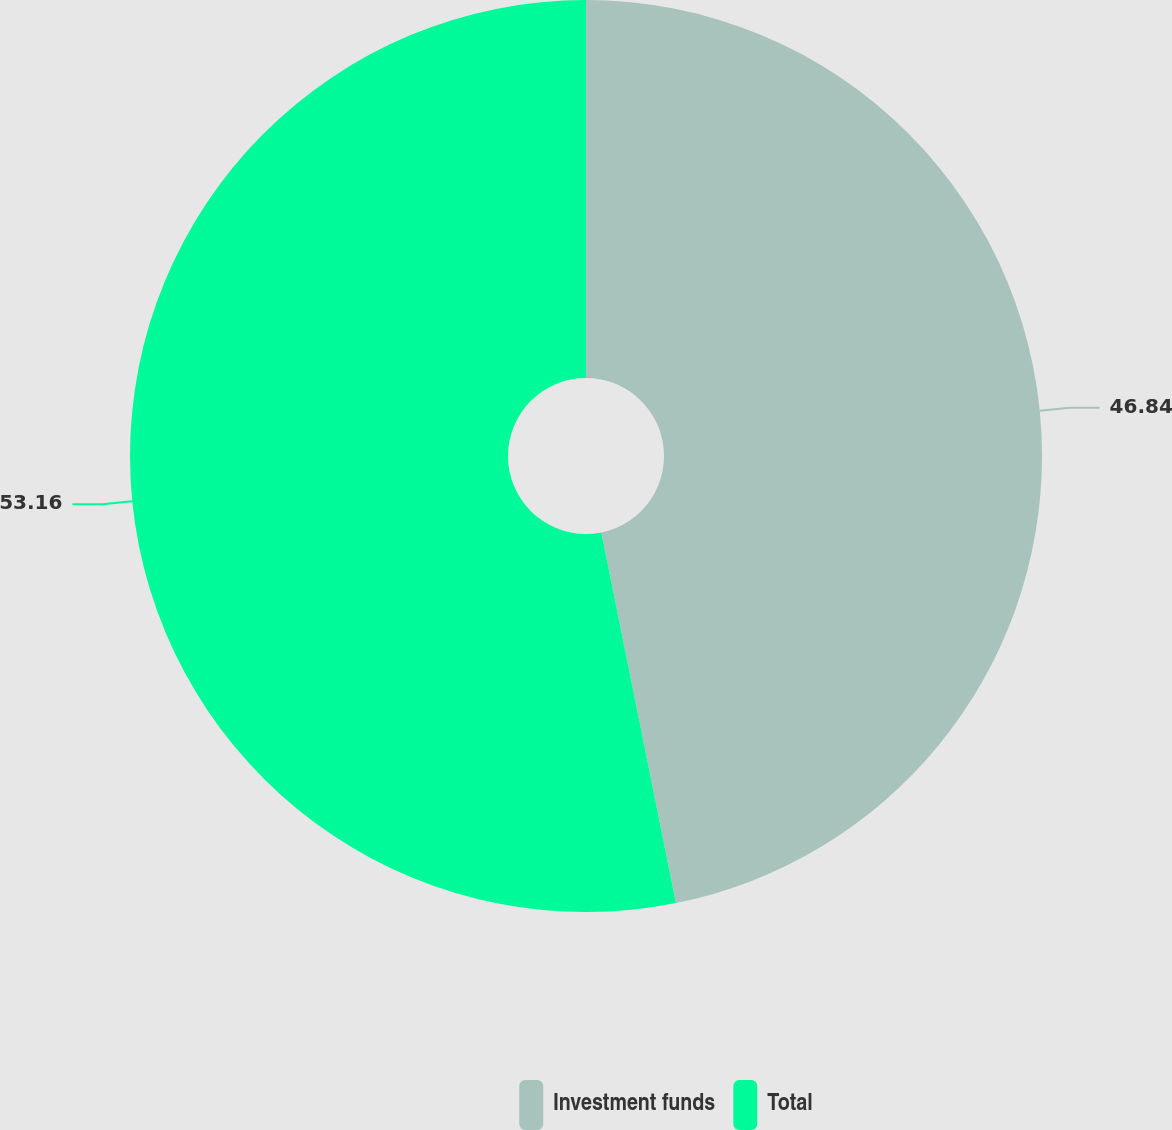Convert chart. <chart><loc_0><loc_0><loc_500><loc_500><pie_chart><fcel>Investment funds<fcel>Total<nl><fcel>46.84%<fcel>53.16%<nl></chart> 